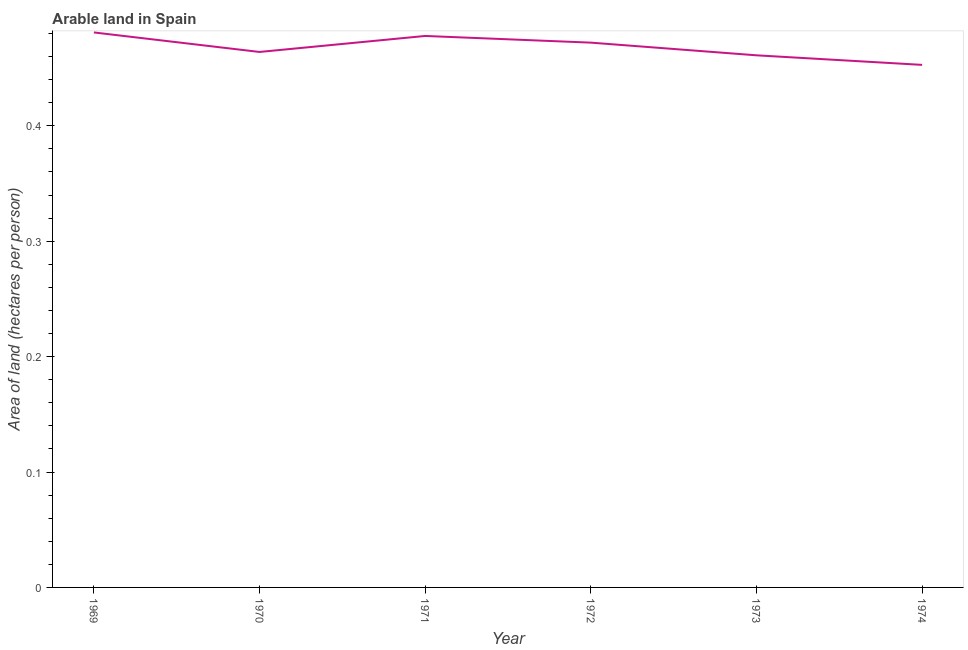What is the area of arable land in 1973?
Offer a very short reply. 0.46. Across all years, what is the maximum area of arable land?
Your answer should be compact. 0.48. Across all years, what is the minimum area of arable land?
Ensure brevity in your answer.  0.45. In which year was the area of arable land maximum?
Offer a terse response. 1969. In which year was the area of arable land minimum?
Offer a very short reply. 1974. What is the sum of the area of arable land?
Give a very brief answer. 2.81. What is the difference between the area of arable land in 1973 and 1974?
Provide a succinct answer. 0.01. What is the average area of arable land per year?
Give a very brief answer. 0.47. What is the median area of arable land?
Provide a succinct answer. 0.47. Do a majority of the years between 1973 and 1972 (inclusive) have area of arable land greater than 0.28 hectares per person?
Give a very brief answer. No. What is the ratio of the area of arable land in 1972 to that in 1974?
Your answer should be very brief. 1.04. Is the area of arable land in 1971 less than that in 1973?
Offer a terse response. No. Is the difference between the area of arable land in 1970 and 1972 greater than the difference between any two years?
Your answer should be compact. No. What is the difference between the highest and the second highest area of arable land?
Your answer should be very brief. 0. What is the difference between the highest and the lowest area of arable land?
Your answer should be very brief. 0.03. How many years are there in the graph?
Offer a very short reply. 6. Are the values on the major ticks of Y-axis written in scientific E-notation?
Provide a short and direct response. No. What is the title of the graph?
Ensure brevity in your answer.  Arable land in Spain. What is the label or title of the Y-axis?
Provide a succinct answer. Area of land (hectares per person). What is the Area of land (hectares per person) of 1969?
Your response must be concise. 0.48. What is the Area of land (hectares per person) of 1970?
Give a very brief answer. 0.46. What is the Area of land (hectares per person) in 1971?
Your answer should be compact. 0.48. What is the Area of land (hectares per person) of 1972?
Ensure brevity in your answer.  0.47. What is the Area of land (hectares per person) in 1973?
Offer a very short reply. 0.46. What is the Area of land (hectares per person) in 1974?
Your answer should be very brief. 0.45. What is the difference between the Area of land (hectares per person) in 1969 and 1970?
Ensure brevity in your answer.  0.02. What is the difference between the Area of land (hectares per person) in 1969 and 1971?
Your answer should be very brief. 0. What is the difference between the Area of land (hectares per person) in 1969 and 1972?
Ensure brevity in your answer.  0.01. What is the difference between the Area of land (hectares per person) in 1969 and 1973?
Your answer should be compact. 0.02. What is the difference between the Area of land (hectares per person) in 1969 and 1974?
Your response must be concise. 0.03. What is the difference between the Area of land (hectares per person) in 1970 and 1971?
Keep it short and to the point. -0.01. What is the difference between the Area of land (hectares per person) in 1970 and 1972?
Provide a succinct answer. -0.01. What is the difference between the Area of land (hectares per person) in 1970 and 1973?
Give a very brief answer. 0. What is the difference between the Area of land (hectares per person) in 1970 and 1974?
Provide a short and direct response. 0.01. What is the difference between the Area of land (hectares per person) in 1971 and 1972?
Provide a short and direct response. 0.01. What is the difference between the Area of land (hectares per person) in 1971 and 1973?
Provide a succinct answer. 0.02. What is the difference between the Area of land (hectares per person) in 1971 and 1974?
Provide a short and direct response. 0.03. What is the difference between the Area of land (hectares per person) in 1972 and 1973?
Your answer should be very brief. 0.01. What is the difference between the Area of land (hectares per person) in 1972 and 1974?
Your answer should be very brief. 0.02. What is the difference between the Area of land (hectares per person) in 1973 and 1974?
Keep it short and to the point. 0.01. What is the ratio of the Area of land (hectares per person) in 1969 to that in 1970?
Provide a succinct answer. 1.04. What is the ratio of the Area of land (hectares per person) in 1969 to that in 1971?
Offer a very short reply. 1.01. What is the ratio of the Area of land (hectares per person) in 1969 to that in 1972?
Offer a terse response. 1.02. What is the ratio of the Area of land (hectares per person) in 1969 to that in 1973?
Make the answer very short. 1.04. What is the ratio of the Area of land (hectares per person) in 1969 to that in 1974?
Offer a very short reply. 1.06. What is the ratio of the Area of land (hectares per person) in 1970 to that in 1974?
Give a very brief answer. 1.02. What is the ratio of the Area of land (hectares per person) in 1971 to that in 1973?
Keep it short and to the point. 1.04. What is the ratio of the Area of land (hectares per person) in 1971 to that in 1974?
Your answer should be very brief. 1.05. What is the ratio of the Area of land (hectares per person) in 1972 to that in 1973?
Your response must be concise. 1.02. What is the ratio of the Area of land (hectares per person) in 1972 to that in 1974?
Ensure brevity in your answer.  1.04. What is the ratio of the Area of land (hectares per person) in 1973 to that in 1974?
Your answer should be very brief. 1.02. 